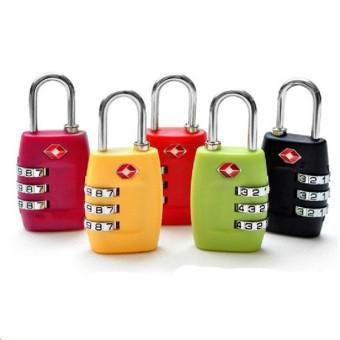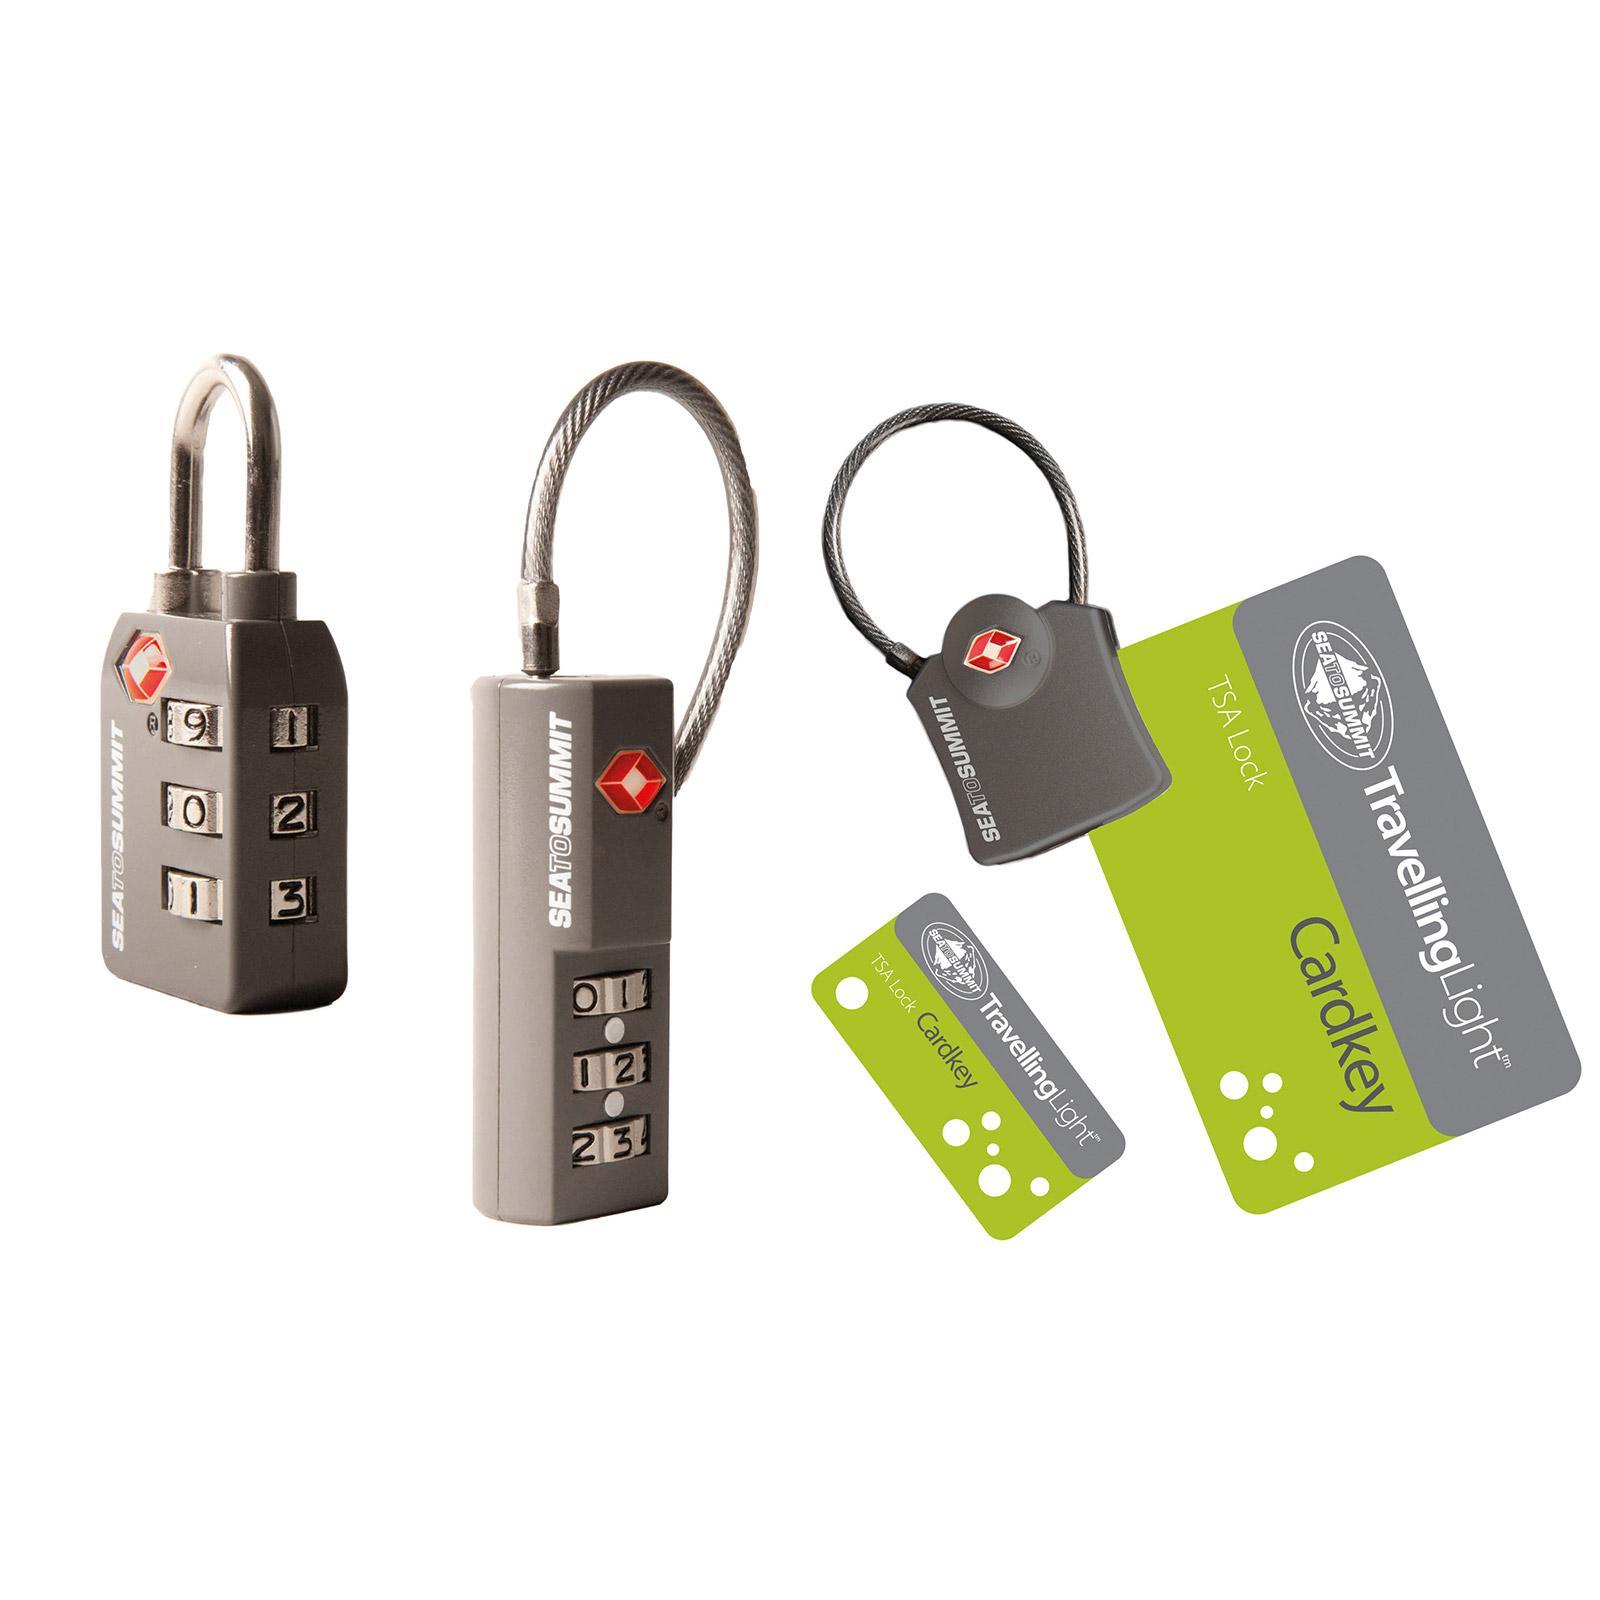The first image is the image on the left, the second image is the image on the right. Given the left and right images, does the statement "One image has items other than one or more locks." hold true? Answer yes or no. Yes. The first image is the image on the left, the second image is the image on the right. Evaluate the accuracy of this statement regarding the images: "there is no more then two locks in the right side image". Is it true? Answer yes or no. No. 